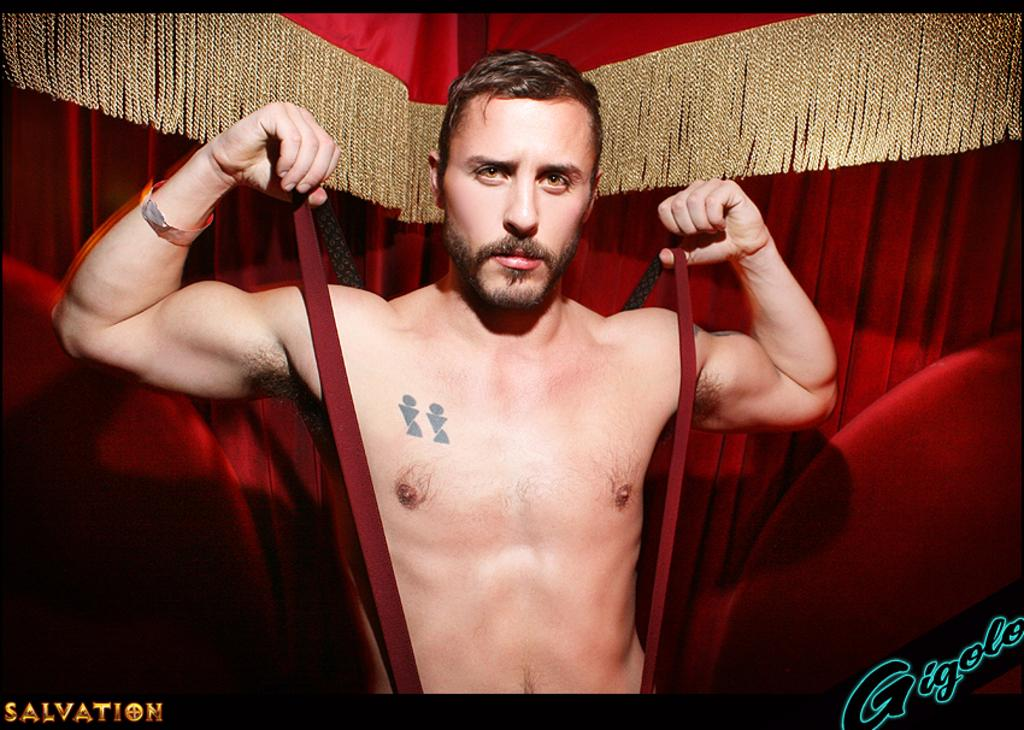What is the main subject of the image? There is a man standing in the image. What can be seen in the background of the image? There is a curtain in the background of the image. What color is the curtain? The curtain is red in color. What type of approval can be seen on the banana in the image? There is no banana present in the image, and therefore no approval can be seen on it. 